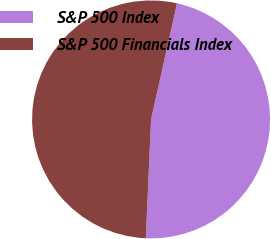Convert chart to OTSL. <chart><loc_0><loc_0><loc_500><loc_500><pie_chart><fcel>S&P 500 Index<fcel>S&P 500 Financials Index<nl><fcel>47.2%<fcel>52.8%<nl></chart> 